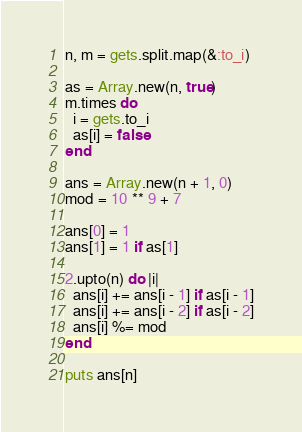<code> <loc_0><loc_0><loc_500><loc_500><_Ruby_>n, m = gets.split.map(&:to_i)

as = Array.new(n, true)
m.times do
  i = gets.to_i
  as[i] = false
end

ans = Array.new(n + 1, 0)
mod = 10 ** 9 + 7

ans[0] = 1
ans[1] = 1 if as[1]

2.upto(n) do |i|
  ans[i] += ans[i - 1] if as[i - 1]
  ans[i] += ans[i - 2] if as[i - 2]
  ans[i] %= mod
end

puts ans[n]
</code> 